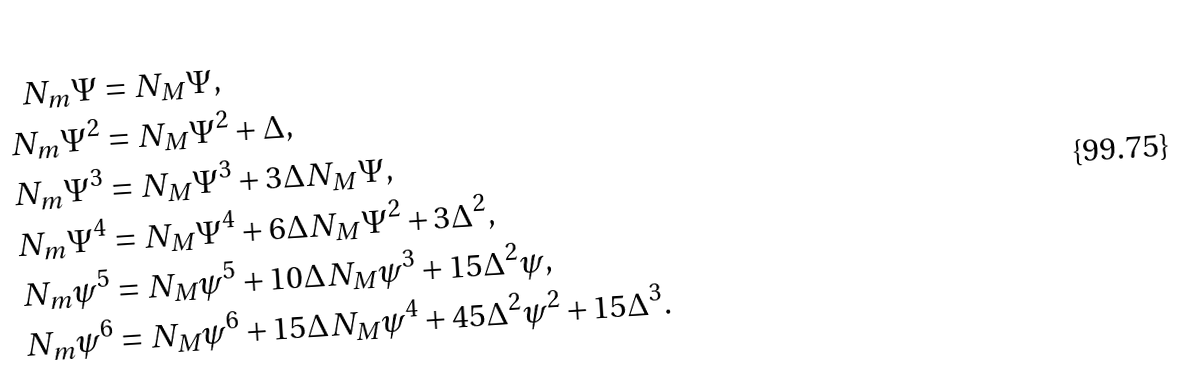Convert formula to latex. <formula><loc_0><loc_0><loc_500><loc_500>N _ { m } \Psi & = N _ { M } \Psi , \\ N _ { m } \Psi ^ { 2 } & = N _ { M } \Psi ^ { 2 } + \Delta , \\ N _ { m } \Psi ^ { 3 } & = N _ { M } \Psi ^ { 3 } + 3 \Delta N _ { M } \Psi , \\ N _ { m } \Psi ^ { 4 } & = N _ { M } \Psi ^ { 4 } + 6 \Delta N _ { M } \Psi ^ { 2 } + 3 \Delta ^ { 2 } , \\ N _ { m } \psi ^ { 5 } & = N _ { M } \psi ^ { 5 } + 1 0 \Delta N _ { M } \psi ^ { 3 } + 1 5 \Delta ^ { 2 } \psi , \\ N _ { m } \psi ^ { 6 } & = N _ { M } \psi ^ { 6 } + 1 5 \Delta N _ { M } \psi ^ { 4 } + 4 5 \Delta ^ { 2 } \psi ^ { 2 } + 1 5 \Delta ^ { 3 } .</formula> 